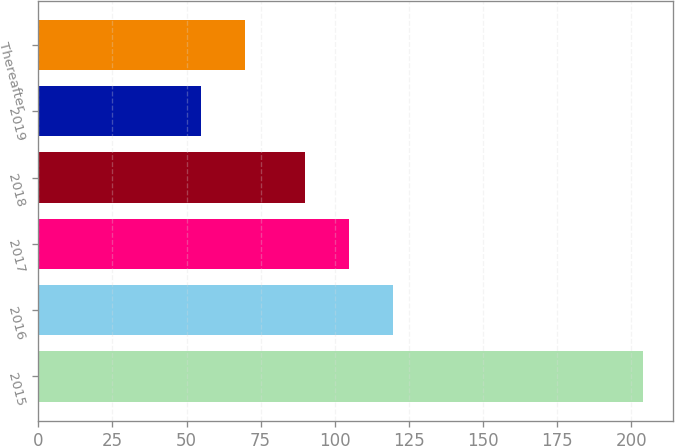Convert chart. <chart><loc_0><loc_0><loc_500><loc_500><bar_chart><fcel>2015<fcel>2016<fcel>2017<fcel>2018<fcel>2019<fcel>Thereafter<nl><fcel>204<fcel>119.8<fcel>104.9<fcel>90<fcel>55<fcel>69.9<nl></chart> 